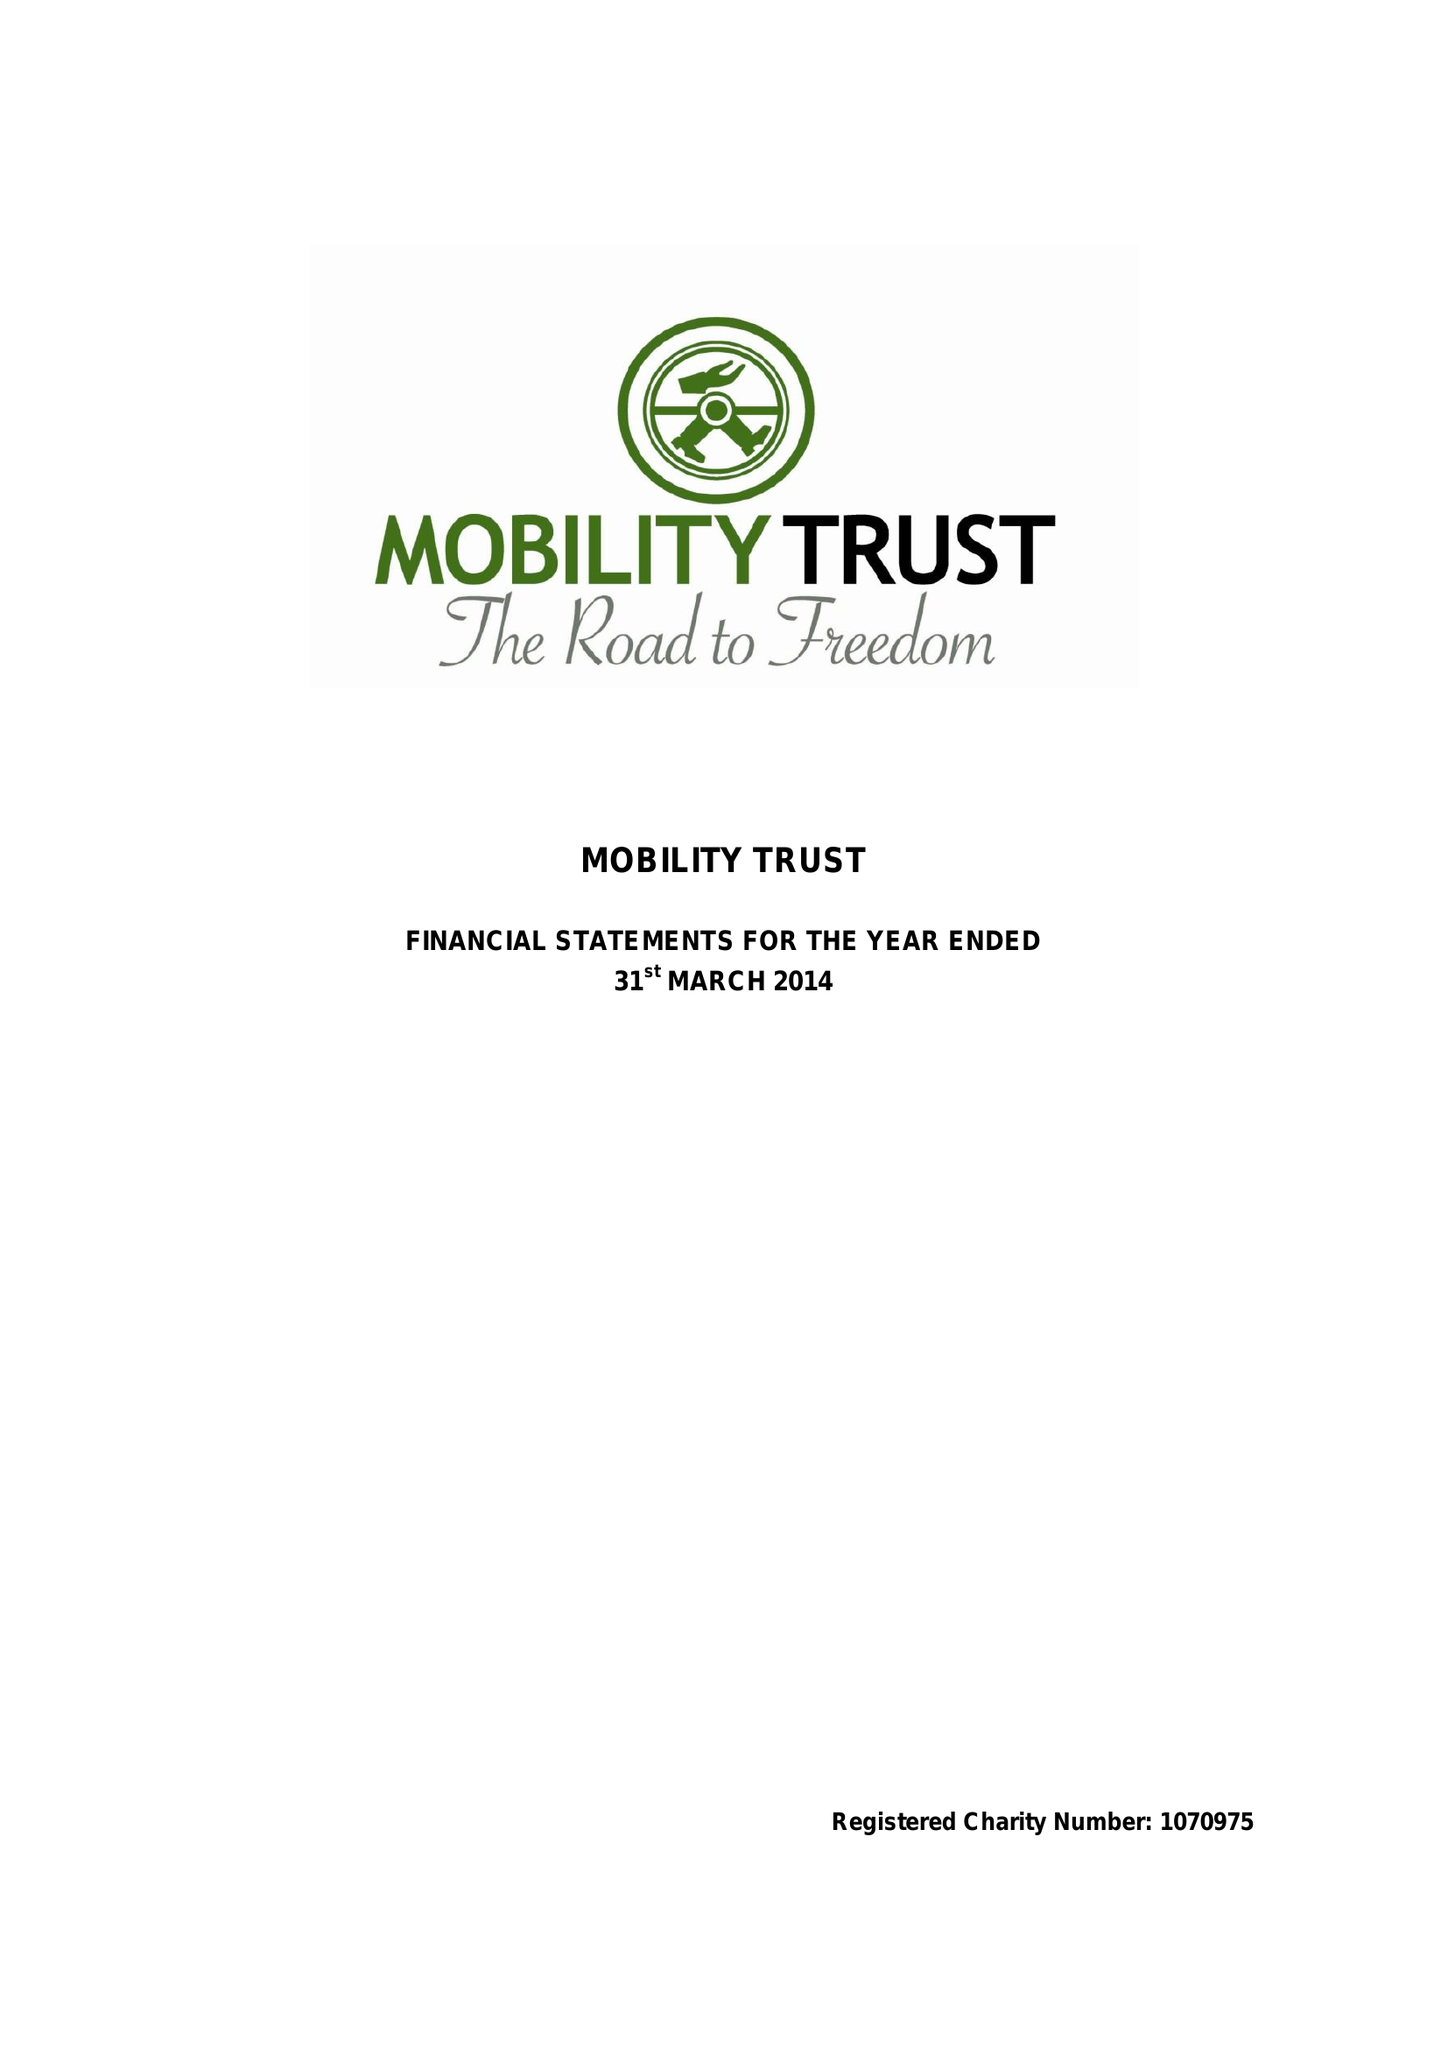What is the value for the charity_name?
Answer the question using a single word or phrase. Mobility Trust Ii 